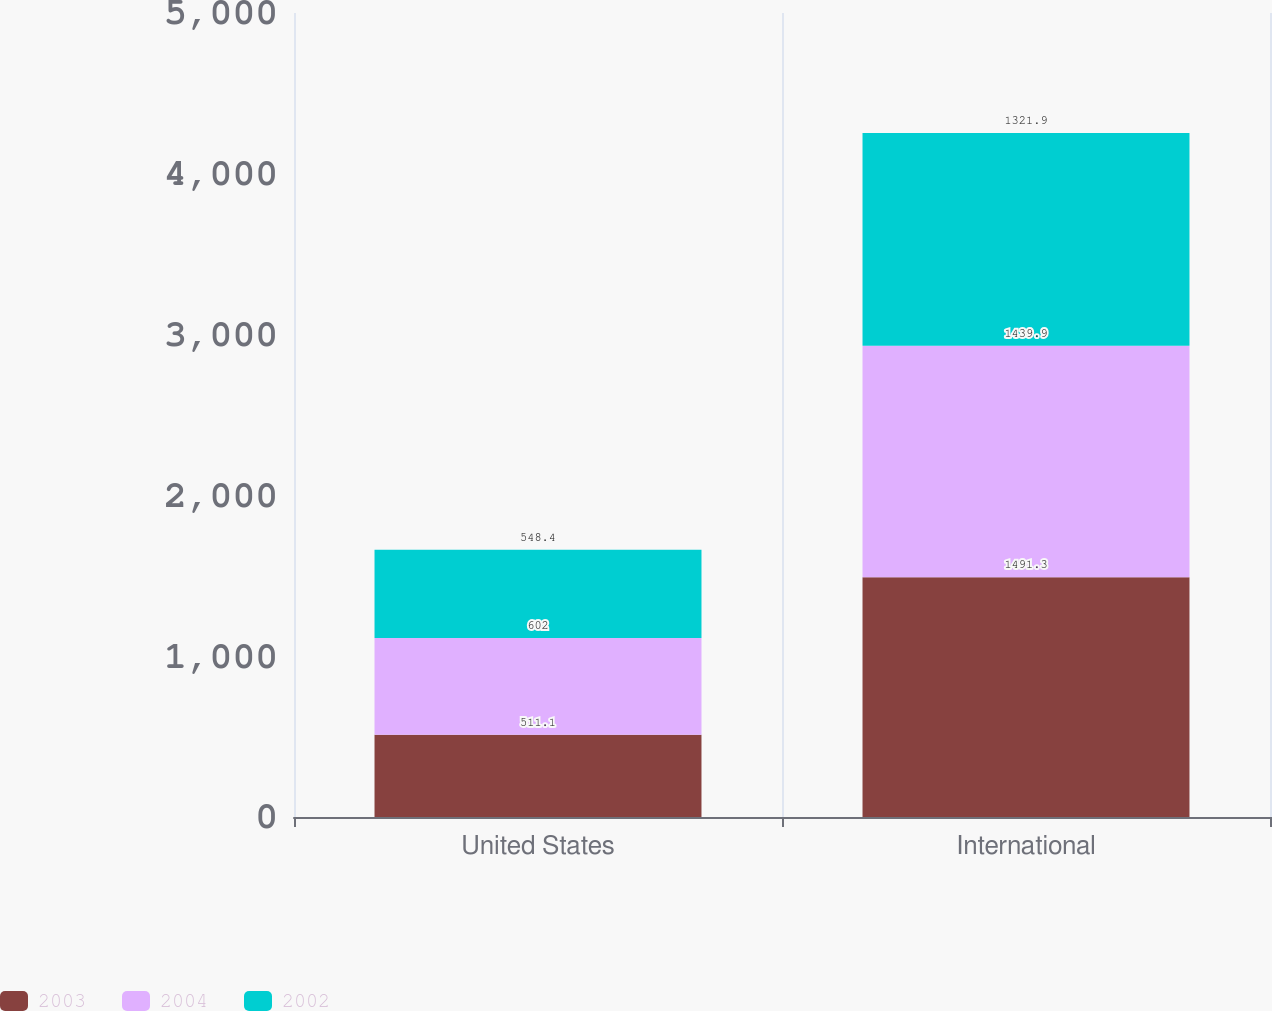Convert chart. <chart><loc_0><loc_0><loc_500><loc_500><stacked_bar_chart><ecel><fcel>United States<fcel>International<nl><fcel>2003<fcel>511.1<fcel>1491.3<nl><fcel>2004<fcel>602<fcel>1439.9<nl><fcel>2002<fcel>548.4<fcel>1321.9<nl></chart> 